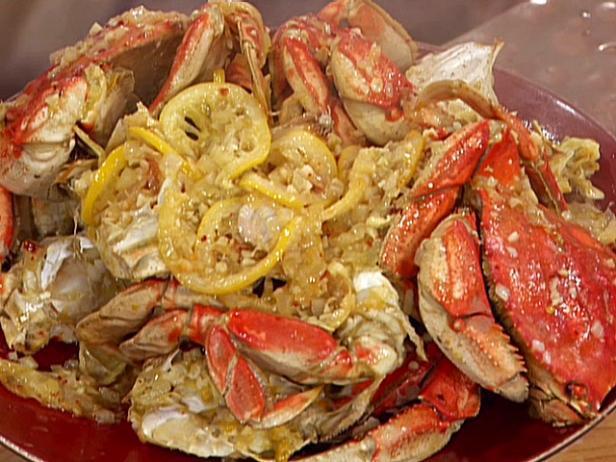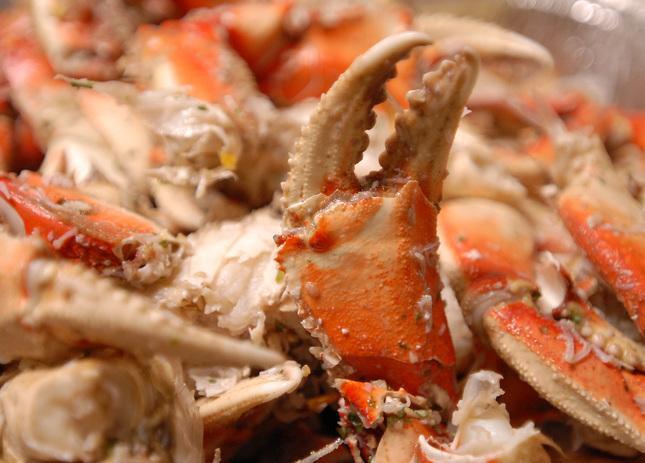The first image is the image on the left, the second image is the image on the right. Analyze the images presented: Is the assertion "A single whole crab is on a white plate with dipping sauce next to it." valid? Answer yes or no. No. The first image is the image on the left, the second image is the image on the right. Examine the images to the left and right. Is the description "There are crab legs separated from the body." accurate? Answer yes or no. Yes. 